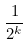<formula> <loc_0><loc_0><loc_500><loc_500>\frac { 1 } { 2 ^ { k } }</formula> 